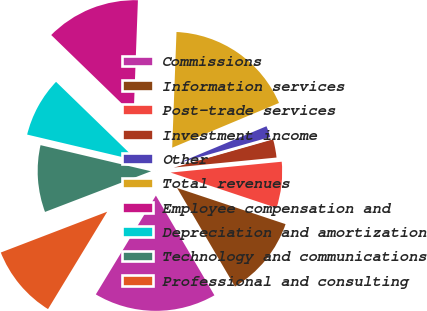<chart> <loc_0><loc_0><loc_500><loc_500><pie_chart><fcel>Commissions<fcel>Information services<fcel>Post-trade services<fcel>Investment income<fcel>Other<fcel>Total revenues<fcel>Employee compensation and<fcel>Depreciation and amortization<fcel>Technology and communications<fcel>Professional and consulting<nl><fcel>17.14%<fcel>11.43%<fcel>6.67%<fcel>2.86%<fcel>1.9%<fcel>18.1%<fcel>13.33%<fcel>8.57%<fcel>9.52%<fcel>10.48%<nl></chart> 